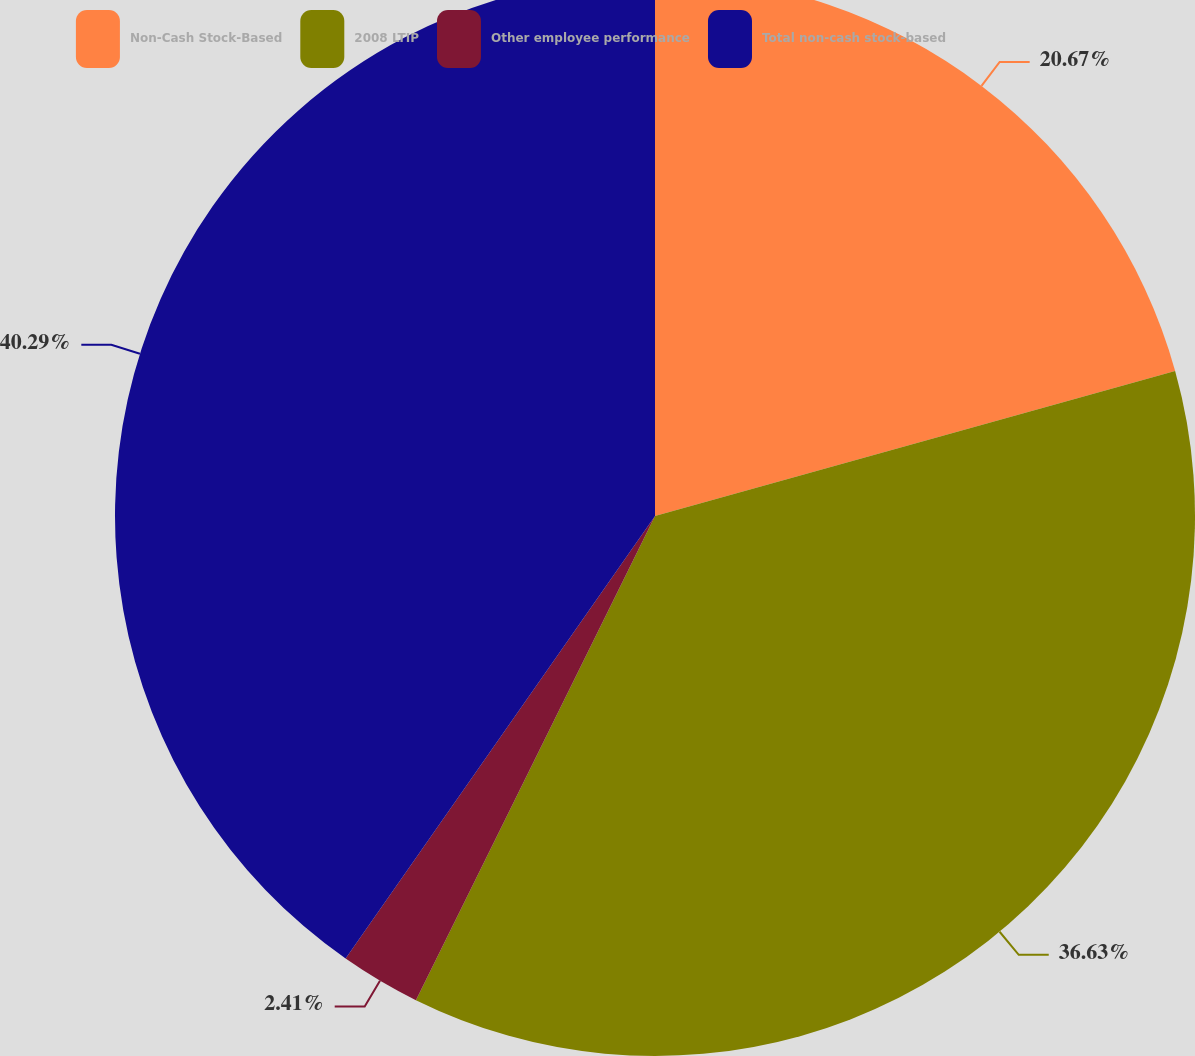Convert chart. <chart><loc_0><loc_0><loc_500><loc_500><pie_chart><fcel>Non-Cash Stock-Based<fcel>2008 LTIP<fcel>Other employee performance<fcel>Total non-cash stock-based<nl><fcel>20.67%<fcel>36.63%<fcel>2.41%<fcel>40.29%<nl></chart> 